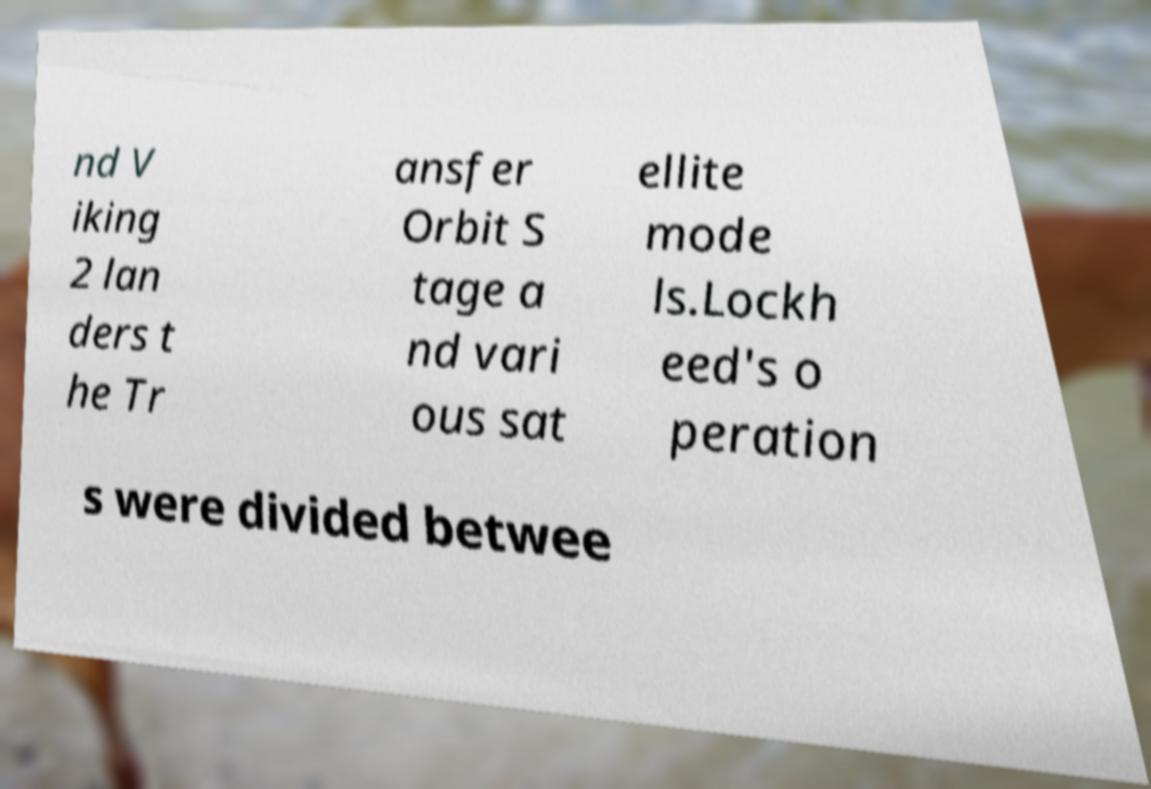Please read and relay the text visible in this image. What does it say? nd V iking 2 lan ders t he Tr ansfer Orbit S tage a nd vari ous sat ellite mode ls.Lockh eed's o peration s were divided betwee 